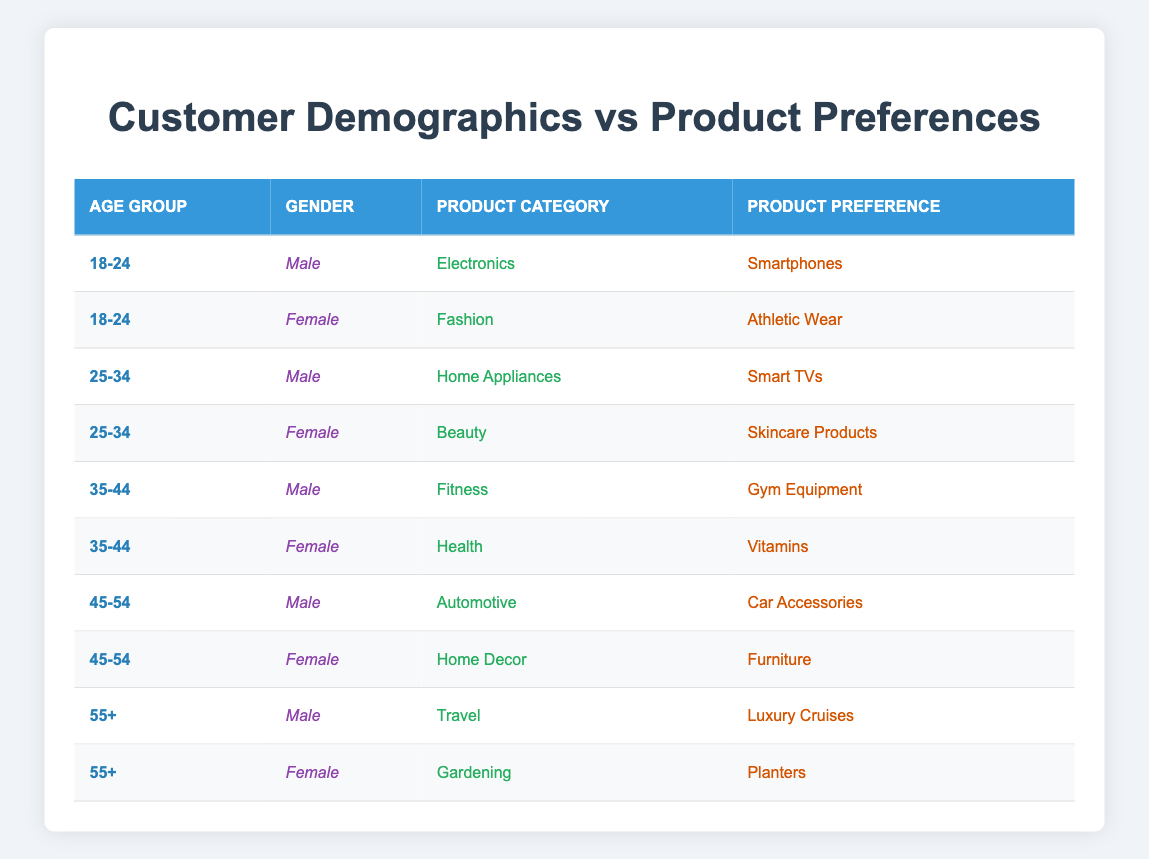What product preference do males in the 18-24 age group have? According to the table, the male customers in the 18-24 age group prefer "Smartphones." This can be directly retrieved from the row corresponding to that specific demographic.
Answer: Smartphones Which product category do the females aged 35-44 prefer? From the table, the females in the 35-44 age group have a preference for "Vitamins." This information is found in the row that lists the 35-44 age group and Female.
Answer: Vitamins True or False: The 45-54 age group has both males and females purchasing "Car Accessories." The table shows that males in the 45-54 age group prefer "Car Accessories," but there is no entry for females in that age group purchasing the same product. Thus, the statement is false.
Answer: False What is the total number of product categories represented by females in the 18-24 age group? The table shows only one unique product category for the females in the 18-24 age group, which is "Fashion." To find the total, we review the rows related to that age group and gender.
Answer: 1 How do the product preferences differ between males and females aged 25-34? Males in the 25-34 age group prefer "Smart TVs" under Home Appliances, while females prefer "Skincare Products" under Beauty. Both preferences are noted in their respective rows, showing a distinct difference between genders in the same age group.
Answer: Different products What is the product preference for females in the age group 55 and older? The table details two different product preferences for females aged 55 and older: "Planters" under Gardening. This is confirmed by checking the entries in that specific age group for females.
Answer: Planters Are there any males in the 35-44 age group who prefer beauty products? Reviewing the table reveals that the males aged 35-44 prefer "Gym Equipment," indicating they do not prefer beauty products. Hence, the answer is NO.
Answer: No How many males prefer travel-related products across all age groups? The table shows that the only males who are indicated to prefer travel products are in the 55+ age group with a preference for "Luxury Cruises." Thus, there is one unique entry for males.
Answer: 1 